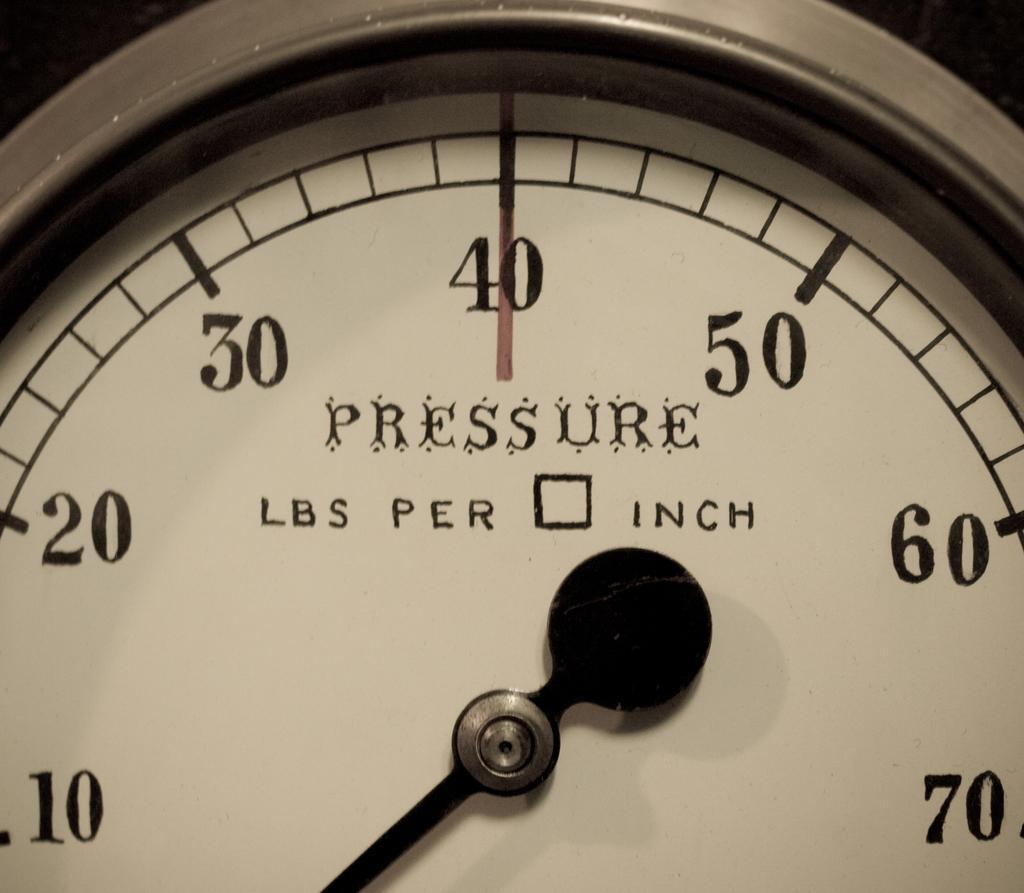How would you summarize this image in a sentence or two? In this image there is a meter having a indicator. Behind there are few numbers and text on the frame. 